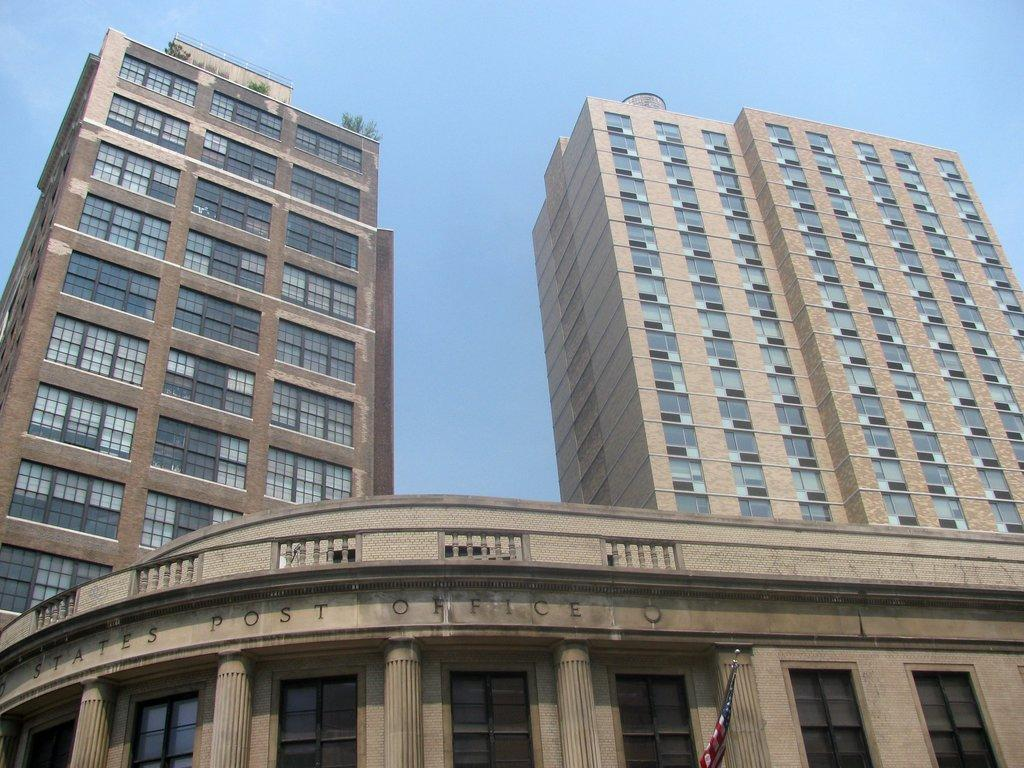What type of structures are present in the image? There are buildings in the image. Can you describe any specific features of the buildings? Yes, there are plants on one of the buildings on the left side. What else can be seen in the image besides the buildings? There is a flag visible in the image. What direction is the brother walking in the image? There is no brother present in the image, so it is not possible to answer that question. 